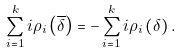<formula> <loc_0><loc_0><loc_500><loc_500>\sum _ { i = 1 } ^ { k } i \rho _ { i } \left ( \overline { \delta } \right ) = - \sum _ { i = 1 } ^ { k } i \rho _ { i } \left ( \delta \right ) .</formula> 